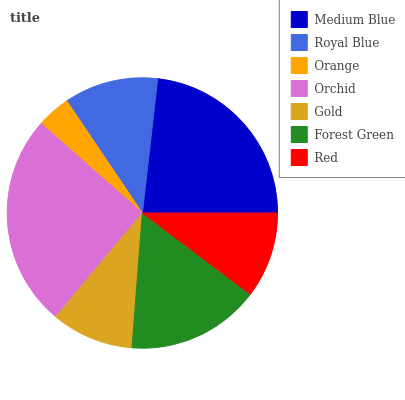Is Orange the minimum?
Answer yes or no. Yes. Is Orchid the maximum?
Answer yes or no. Yes. Is Royal Blue the minimum?
Answer yes or no. No. Is Royal Blue the maximum?
Answer yes or no. No. Is Medium Blue greater than Royal Blue?
Answer yes or no. Yes. Is Royal Blue less than Medium Blue?
Answer yes or no. Yes. Is Royal Blue greater than Medium Blue?
Answer yes or no. No. Is Medium Blue less than Royal Blue?
Answer yes or no. No. Is Royal Blue the high median?
Answer yes or no. Yes. Is Royal Blue the low median?
Answer yes or no. Yes. Is Orange the high median?
Answer yes or no. No. Is Medium Blue the low median?
Answer yes or no. No. 